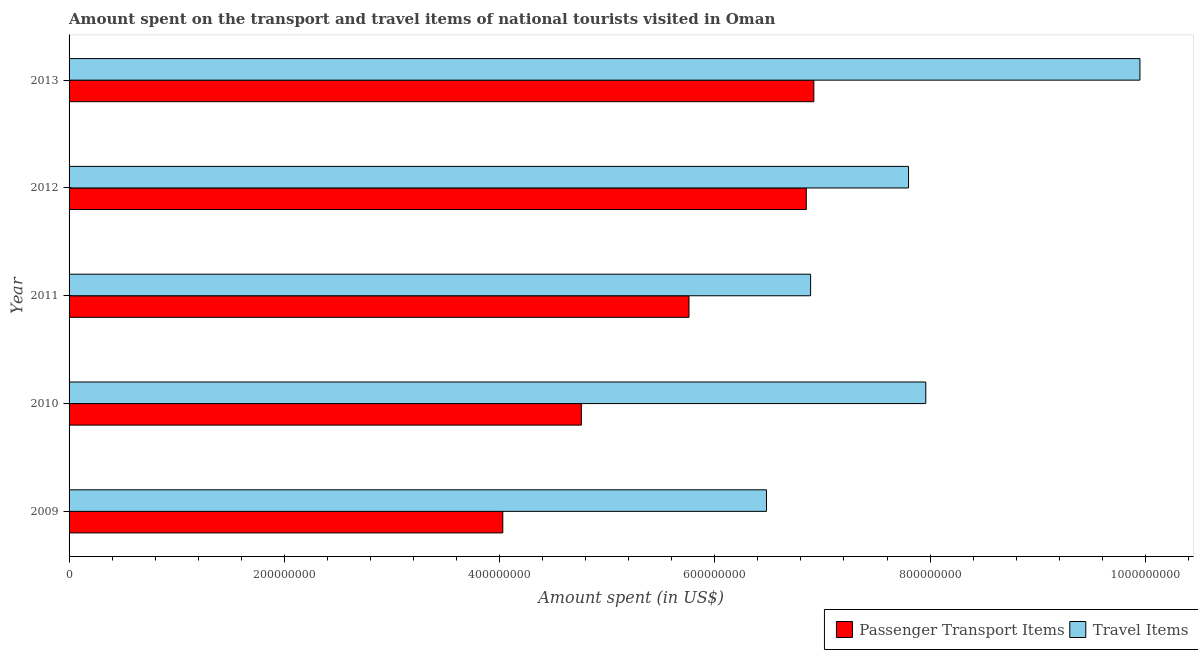How many groups of bars are there?
Provide a succinct answer. 5. How many bars are there on the 5th tick from the top?
Your answer should be very brief. 2. In how many cases, is the number of bars for a given year not equal to the number of legend labels?
Keep it short and to the point. 0. What is the amount spent on passenger transport items in 2011?
Keep it short and to the point. 5.76e+08. Across all years, what is the maximum amount spent on passenger transport items?
Your response must be concise. 6.92e+08. Across all years, what is the minimum amount spent on passenger transport items?
Provide a succinct answer. 4.03e+08. In which year was the amount spent on passenger transport items maximum?
Provide a succinct answer. 2013. In which year was the amount spent in travel items minimum?
Your answer should be compact. 2009. What is the total amount spent in travel items in the graph?
Offer a very short reply. 3.91e+09. What is the difference between the amount spent in travel items in 2009 and that in 2013?
Ensure brevity in your answer.  -3.47e+08. What is the difference between the amount spent in travel items in 2009 and the amount spent on passenger transport items in 2013?
Offer a terse response. -4.40e+07. What is the average amount spent in travel items per year?
Offer a terse response. 7.82e+08. In the year 2011, what is the difference between the amount spent in travel items and amount spent on passenger transport items?
Offer a terse response. 1.13e+08. In how many years, is the amount spent on passenger transport items greater than 160000000 US$?
Provide a short and direct response. 5. Is the amount spent in travel items in 2010 less than that in 2013?
Make the answer very short. Yes. What is the difference between the highest and the second highest amount spent on passenger transport items?
Ensure brevity in your answer.  7.00e+06. What is the difference between the highest and the lowest amount spent on passenger transport items?
Provide a succinct answer. 2.89e+08. What does the 2nd bar from the top in 2013 represents?
Give a very brief answer. Passenger Transport Items. What does the 1st bar from the bottom in 2009 represents?
Keep it short and to the point. Passenger Transport Items. How many years are there in the graph?
Make the answer very short. 5. Are the values on the major ticks of X-axis written in scientific E-notation?
Provide a succinct answer. No. Does the graph contain grids?
Make the answer very short. No. How many legend labels are there?
Provide a short and direct response. 2. How are the legend labels stacked?
Make the answer very short. Horizontal. What is the title of the graph?
Provide a short and direct response. Amount spent on the transport and travel items of national tourists visited in Oman. What is the label or title of the X-axis?
Your response must be concise. Amount spent (in US$). What is the label or title of the Y-axis?
Ensure brevity in your answer.  Year. What is the Amount spent (in US$) of Passenger Transport Items in 2009?
Give a very brief answer. 4.03e+08. What is the Amount spent (in US$) of Travel Items in 2009?
Provide a short and direct response. 6.48e+08. What is the Amount spent (in US$) in Passenger Transport Items in 2010?
Provide a short and direct response. 4.76e+08. What is the Amount spent (in US$) in Travel Items in 2010?
Ensure brevity in your answer.  7.96e+08. What is the Amount spent (in US$) of Passenger Transport Items in 2011?
Your answer should be very brief. 5.76e+08. What is the Amount spent (in US$) of Travel Items in 2011?
Your answer should be very brief. 6.89e+08. What is the Amount spent (in US$) in Passenger Transport Items in 2012?
Provide a succinct answer. 6.85e+08. What is the Amount spent (in US$) in Travel Items in 2012?
Your answer should be compact. 7.80e+08. What is the Amount spent (in US$) of Passenger Transport Items in 2013?
Make the answer very short. 6.92e+08. What is the Amount spent (in US$) in Travel Items in 2013?
Provide a succinct answer. 9.95e+08. Across all years, what is the maximum Amount spent (in US$) in Passenger Transport Items?
Ensure brevity in your answer.  6.92e+08. Across all years, what is the maximum Amount spent (in US$) of Travel Items?
Provide a succinct answer. 9.95e+08. Across all years, what is the minimum Amount spent (in US$) in Passenger Transport Items?
Your response must be concise. 4.03e+08. Across all years, what is the minimum Amount spent (in US$) of Travel Items?
Ensure brevity in your answer.  6.48e+08. What is the total Amount spent (in US$) in Passenger Transport Items in the graph?
Make the answer very short. 2.83e+09. What is the total Amount spent (in US$) of Travel Items in the graph?
Your answer should be very brief. 3.91e+09. What is the difference between the Amount spent (in US$) in Passenger Transport Items in 2009 and that in 2010?
Offer a very short reply. -7.30e+07. What is the difference between the Amount spent (in US$) of Travel Items in 2009 and that in 2010?
Offer a very short reply. -1.48e+08. What is the difference between the Amount spent (in US$) of Passenger Transport Items in 2009 and that in 2011?
Your response must be concise. -1.73e+08. What is the difference between the Amount spent (in US$) in Travel Items in 2009 and that in 2011?
Ensure brevity in your answer.  -4.10e+07. What is the difference between the Amount spent (in US$) of Passenger Transport Items in 2009 and that in 2012?
Keep it short and to the point. -2.82e+08. What is the difference between the Amount spent (in US$) in Travel Items in 2009 and that in 2012?
Your answer should be compact. -1.32e+08. What is the difference between the Amount spent (in US$) of Passenger Transport Items in 2009 and that in 2013?
Keep it short and to the point. -2.89e+08. What is the difference between the Amount spent (in US$) in Travel Items in 2009 and that in 2013?
Keep it short and to the point. -3.47e+08. What is the difference between the Amount spent (in US$) in Passenger Transport Items in 2010 and that in 2011?
Keep it short and to the point. -1.00e+08. What is the difference between the Amount spent (in US$) in Travel Items in 2010 and that in 2011?
Your answer should be compact. 1.07e+08. What is the difference between the Amount spent (in US$) of Passenger Transport Items in 2010 and that in 2012?
Your answer should be very brief. -2.09e+08. What is the difference between the Amount spent (in US$) of Travel Items in 2010 and that in 2012?
Offer a very short reply. 1.60e+07. What is the difference between the Amount spent (in US$) in Passenger Transport Items in 2010 and that in 2013?
Provide a succinct answer. -2.16e+08. What is the difference between the Amount spent (in US$) of Travel Items in 2010 and that in 2013?
Provide a succinct answer. -1.99e+08. What is the difference between the Amount spent (in US$) in Passenger Transport Items in 2011 and that in 2012?
Your response must be concise. -1.09e+08. What is the difference between the Amount spent (in US$) of Travel Items in 2011 and that in 2012?
Give a very brief answer. -9.10e+07. What is the difference between the Amount spent (in US$) in Passenger Transport Items in 2011 and that in 2013?
Your response must be concise. -1.16e+08. What is the difference between the Amount spent (in US$) of Travel Items in 2011 and that in 2013?
Offer a terse response. -3.06e+08. What is the difference between the Amount spent (in US$) in Passenger Transport Items in 2012 and that in 2013?
Make the answer very short. -7.00e+06. What is the difference between the Amount spent (in US$) in Travel Items in 2012 and that in 2013?
Provide a succinct answer. -2.15e+08. What is the difference between the Amount spent (in US$) of Passenger Transport Items in 2009 and the Amount spent (in US$) of Travel Items in 2010?
Give a very brief answer. -3.93e+08. What is the difference between the Amount spent (in US$) of Passenger Transport Items in 2009 and the Amount spent (in US$) of Travel Items in 2011?
Keep it short and to the point. -2.86e+08. What is the difference between the Amount spent (in US$) in Passenger Transport Items in 2009 and the Amount spent (in US$) in Travel Items in 2012?
Offer a terse response. -3.77e+08. What is the difference between the Amount spent (in US$) of Passenger Transport Items in 2009 and the Amount spent (in US$) of Travel Items in 2013?
Give a very brief answer. -5.92e+08. What is the difference between the Amount spent (in US$) of Passenger Transport Items in 2010 and the Amount spent (in US$) of Travel Items in 2011?
Offer a very short reply. -2.13e+08. What is the difference between the Amount spent (in US$) in Passenger Transport Items in 2010 and the Amount spent (in US$) in Travel Items in 2012?
Offer a very short reply. -3.04e+08. What is the difference between the Amount spent (in US$) in Passenger Transport Items in 2010 and the Amount spent (in US$) in Travel Items in 2013?
Ensure brevity in your answer.  -5.19e+08. What is the difference between the Amount spent (in US$) of Passenger Transport Items in 2011 and the Amount spent (in US$) of Travel Items in 2012?
Ensure brevity in your answer.  -2.04e+08. What is the difference between the Amount spent (in US$) in Passenger Transport Items in 2011 and the Amount spent (in US$) in Travel Items in 2013?
Offer a terse response. -4.19e+08. What is the difference between the Amount spent (in US$) in Passenger Transport Items in 2012 and the Amount spent (in US$) in Travel Items in 2013?
Offer a terse response. -3.10e+08. What is the average Amount spent (in US$) in Passenger Transport Items per year?
Your answer should be very brief. 5.66e+08. What is the average Amount spent (in US$) in Travel Items per year?
Your answer should be compact. 7.82e+08. In the year 2009, what is the difference between the Amount spent (in US$) of Passenger Transport Items and Amount spent (in US$) of Travel Items?
Give a very brief answer. -2.45e+08. In the year 2010, what is the difference between the Amount spent (in US$) of Passenger Transport Items and Amount spent (in US$) of Travel Items?
Your answer should be very brief. -3.20e+08. In the year 2011, what is the difference between the Amount spent (in US$) of Passenger Transport Items and Amount spent (in US$) of Travel Items?
Ensure brevity in your answer.  -1.13e+08. In the year 2012, what is the difference between the Amount spent (in US$) of Passenger Transport Items and Amount spent (in US$) of Travel Items?
Ensure brevity in your answer.  -9.50e+07. In the year 2013, what is the difference between the Amount spent (in US$) of Passenger Transport Items and Amount spent (in US$) of Travel Items?
Ensure brevity in your answer.  -3.03e+08. What is the ratio of the Amount spent (in US$) in Passenger Transport Items in 2009 to that in 2010?
Your response must be concise. 0.85. What is the ratio of the Amount spent (in US$) in Travel Items in 2009 to that in 2010?
Your answer should be very brief. 0.81. What is the ratio of the Amount spent (in US$) in Passenger Transport Items in 2009 to that in 2011?
Your answer should be compact. 0.7. What is the ratio of the Amount spent (in US$) of Travel Items in 2009 to that in 2011?
Offer a terse response. 0.94. What is the ratio of the Amount spent (in US$) in Passenger Transport Items in 2009 to that in 2012?
Offer a very short reply. 0.59. What is the ratio of the Amount spent (in US$) of Travel Items in 2009 to that in 2012?
Provide a short and direct response. 0.83. What is the ratio of the Amount spent (in US$) of Passenger Transport Items in 2009 to that in 2013?
Offer a terse response. 0.58. What is the ratio of the Amount spent (in US$) in Travel Items in 2009 to that in 2013?
Your answer should be very brief. 0.65. What is the ratio of the Amount spent (in US$) in Passenger Transport Items in 2010 to that in 2011?
Offer a very short reply. 0.83. What is the ratio of the Amount spent (in US$) in Travel Items in 2010 to that in 2011?
Give a very brief answer. 1.16. What is the ratio of the Amount spent (in US$) of Passenger Transport Items in 2010 to that in 2012?
Offer a terse response. 0.69. What is the ratio of the Amount spent (in US$) of Travel Items in 2010 to that in 2012?
Ensure brevity in your answer.  1.02. What is the ratio of the Amount spent (in US$) in Passenger Transport Items in 2010 to that in 2013?
Your answer should be compact. 0.69. What is the ratio of the Amount spent (in US$) in Passenger Transport Items in 2011 to that in 2012?
Your answer should be very brief. 0.84. What is the ratio of the Amount spent (in US$) in Travel Items in 2011 to that in 2012?
Your response must be concise. 0.88. What is the ratio of the Amount spent (in US$) in Passenger Transport Items in 2011 to that in 2013?
Make the answer very short. 0.83. What is the ratio of the Amount spent (in US$) of Travel Items in 2011 to that in 2013?
Provide a succinct answer. 0.69. What is the ratio of the Amount spent (in US$) of Travel Items in 2012 to that in 2013?
Provide a succinct answer. 0.78. What is the difference between the highest and the second highest Amount spent (in US$) in Travel Items?
Provide a succinct answer. 1.99e+08. What is the difference between the highest and the lowest Amount spent (in US$) in Passenger Transport Items?
Provide a short and direct response. 2.89e+08. What is the difference between the highest and the lowest Amount spent (in US$) of Travel Items?
Offer a very short reply. 3.47e+08. 